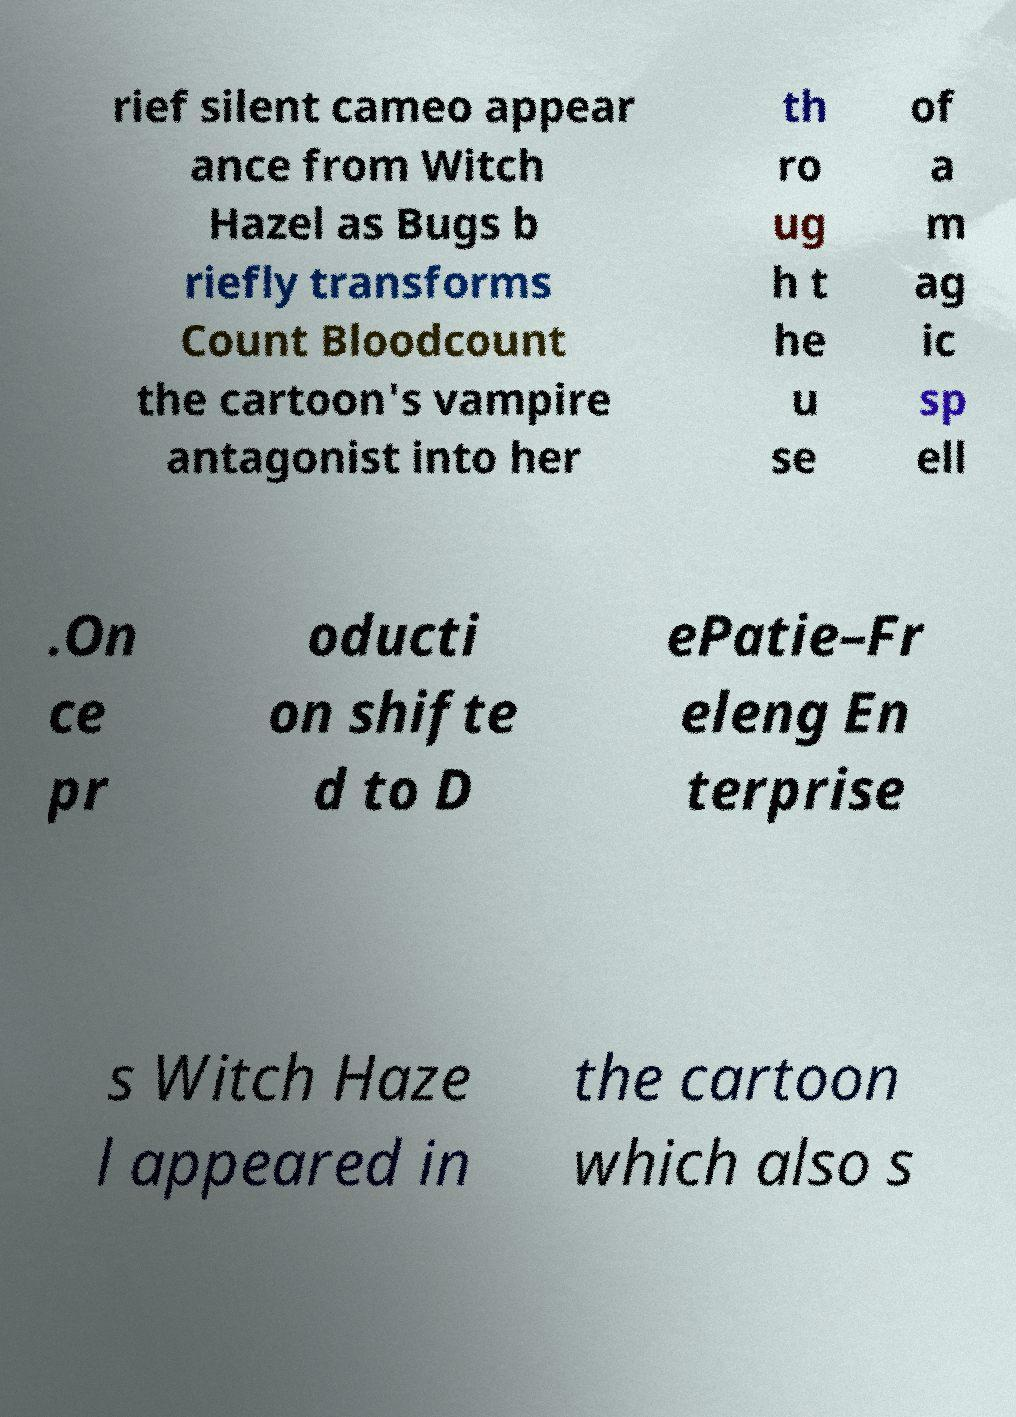For documentation purposes, I need the text within this image transcribed. Could you provide that? rief silent cameo appear ance from Witch Hazel as Bugs b riefly transforms Count Bloodcount the cartoon's vampire antagonist into her th ro ug h t he u se of a m ag ic sp ell .On ce pr oducti on shifte d to D ePatie–Fr eleng En terprise s Witch Haze l appeared in the cartoon which also s 